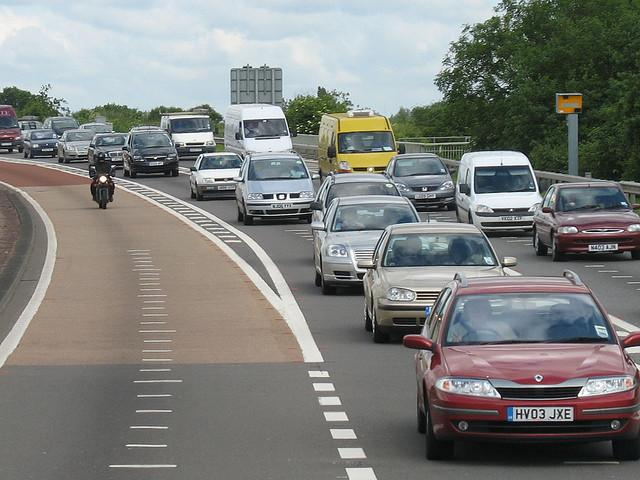Who are the roads for? drivers 